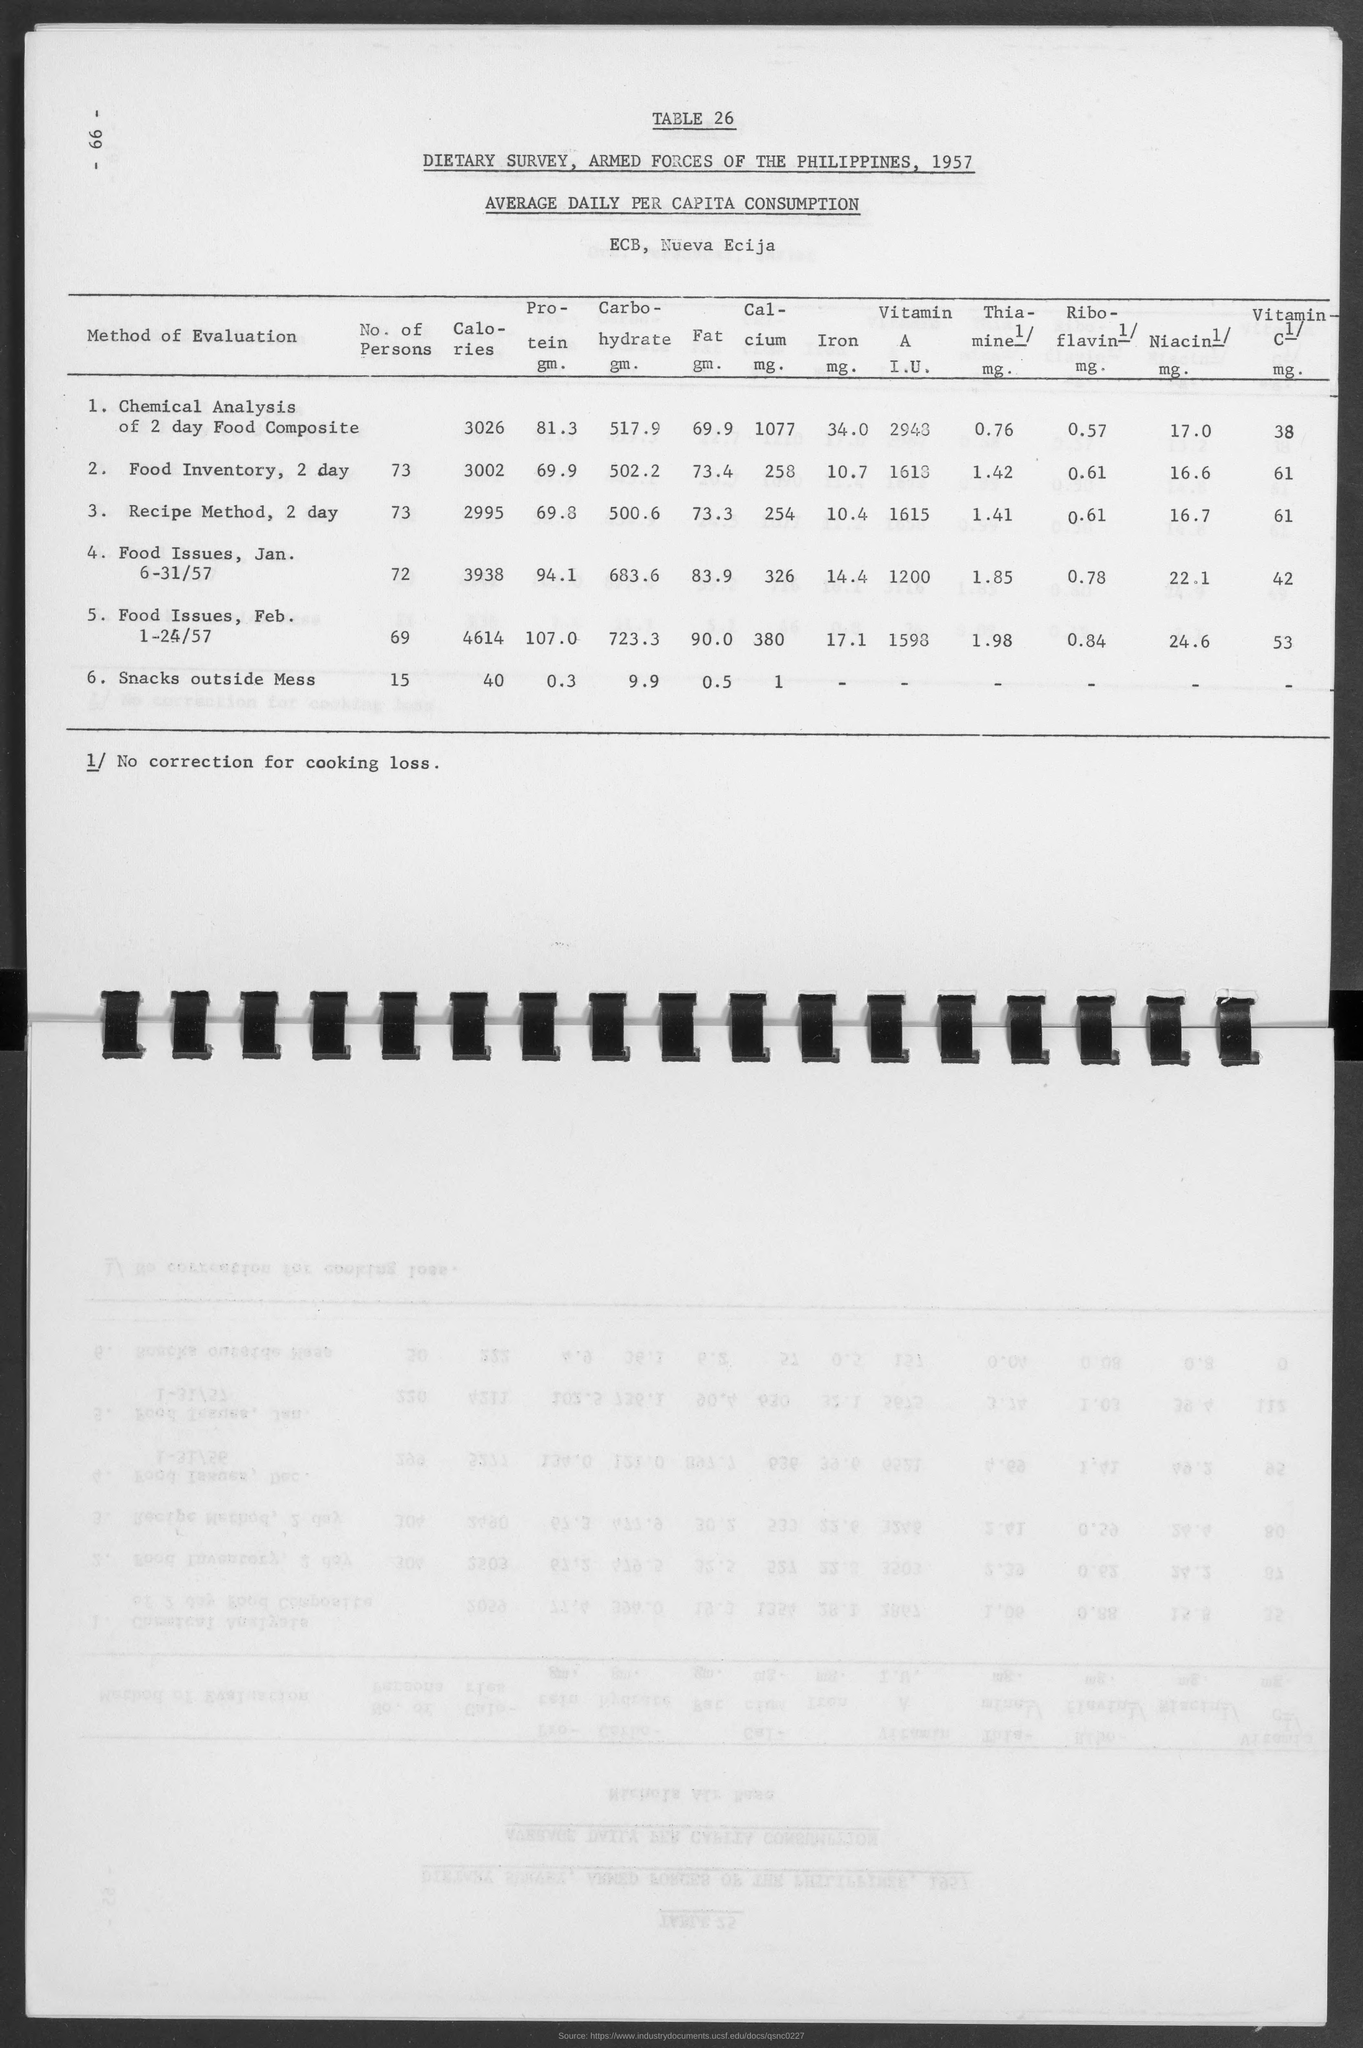What is the table no.?
Keep it short and to the point. 26. What is the amount of calories  for chemical analysis of 2 day food composite?
Your answer should be compact. 3026. What is the amount of calories  for food inventory, 2 day?
Your response must be concise. 3002. What is the amount of calories for recipe method, 2 day?
Offer a terse response. 2995. What is the amount of calories for food issues, jan. 6-31/57?
Your answer should be compact. 3938. What is the amount of calories for food issues, feb. 1-24/57?
Offer a terse response. 4614. What is the amount of calories for snacks outside mess?
Your response must be concise. 40. What is the amount of protein gm. for chemical analysis of 2 day food composite?
Ensure brevity in your answer.  81.3. What is the amount of protein gm. for food inventory, 2 day?
Offer a very short reply. 69.9. What is the amount of protein gm. for recipe method, 2 day?
Provide a short and direct response. 69.8. 